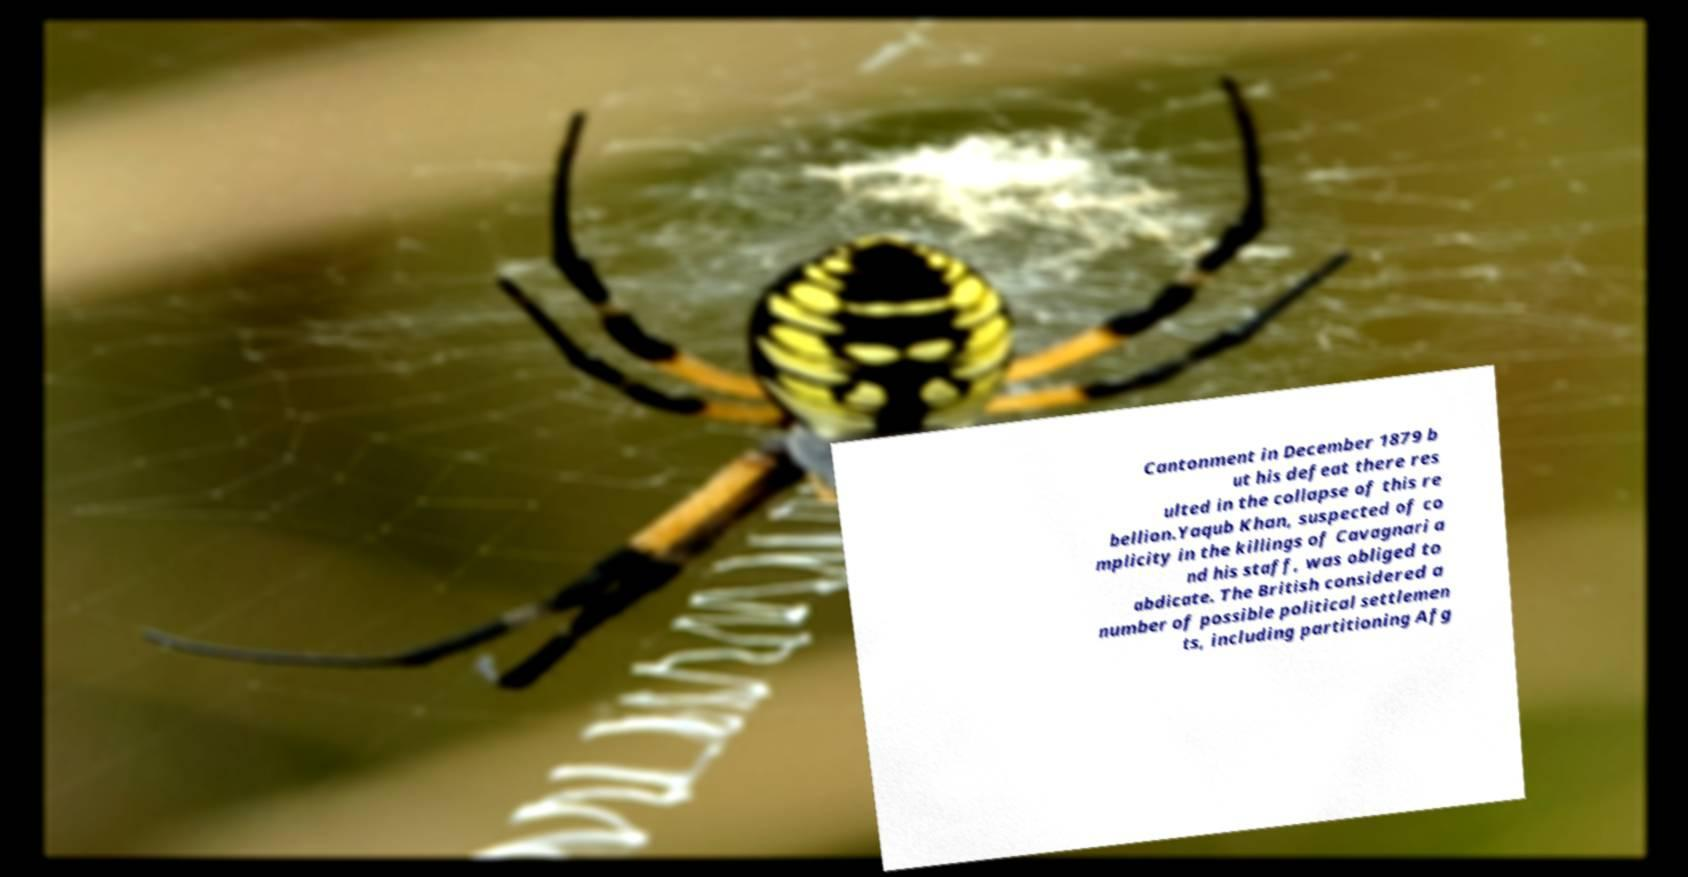Please read and relay the text visible in this image. What does it say? Cantonment in December 1879 b ut his defeat there res ulted in the collapse of this re bellion.Yaqub Khan, suspected of co mplicity in the killings of Cavagnari a nd his staff, was obliged to abdicate. The British considered a number of possible political settlemen ts, including partitioning Afg 